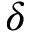<formula> <loc_0><loc_0><loc_500><loc_500>\delta</formula> 